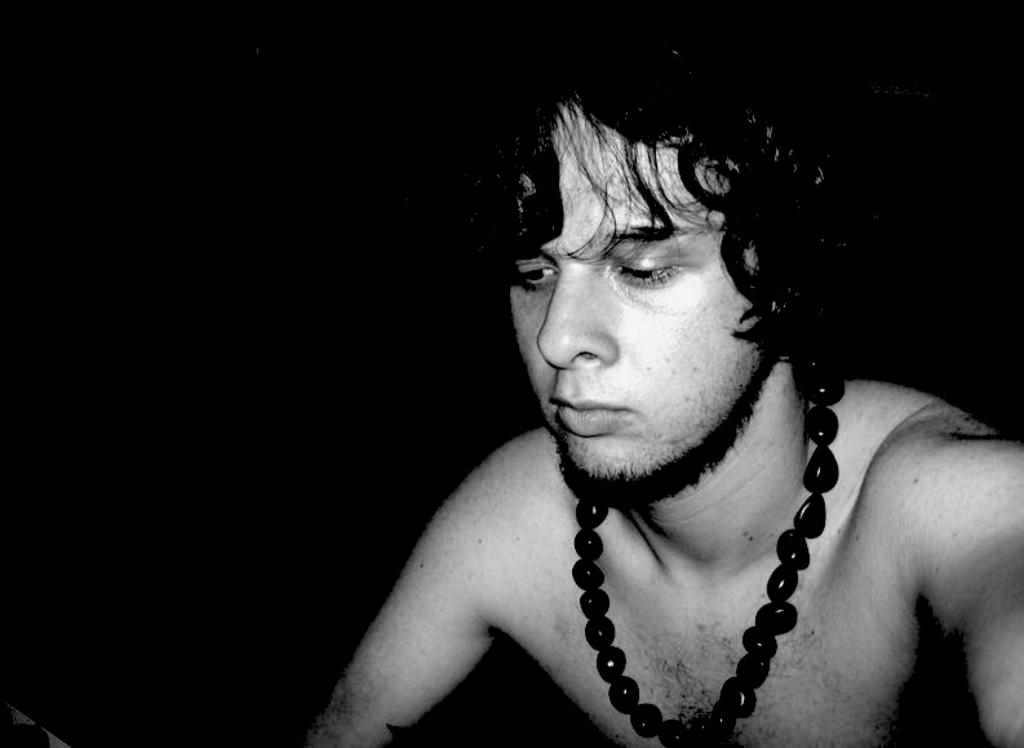What is the main subject of the image? There is a person in the image. Where is the person located in the image? The person is present over a place. What accessory is the person wearing in the image? The person is wearing a pearls chain on his neck. Can you see any snow or a lake in the image? There is no mention of snow or a lake in the provided facts, so we cannot determine their presence in the image. 